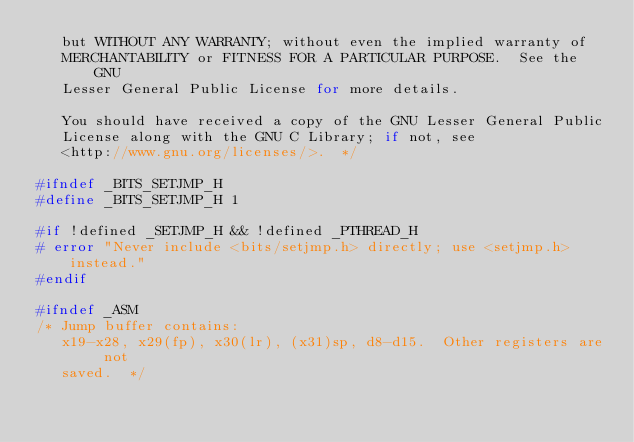Convert code to text. <code><loc_0><loc_0><loc_500><loc_500><_C_>   but WITHOUT ANY WARRANTY; without even the implied warranty of
   MERCHANTABILITY or FITNESS FOR A PARTICULAR PURPOSE.  See the GNU
   Lesser General Public License for more details.

   You should have received a copy of the GNU Lesser General Public
   License along with the GNU C Library; if not, see
   <http://www.gnu.org/licenses/>.  */

#ifndef _BITS_SETJMP_H
#define _BITS_SETJMP_H 1

#if !defined _SETJMP_H && !defined _PTHREAD_H
# error "Never include <bits/setjmp.h> directly; use <setjmp.h> instead."
#endif

#ifndef _ASM
/* Jump buffer contains:
   x19-x28, x29(fp), x30(lr), (x31)sp, d8-d15.  Other registers are not
   saved.  */</code> 